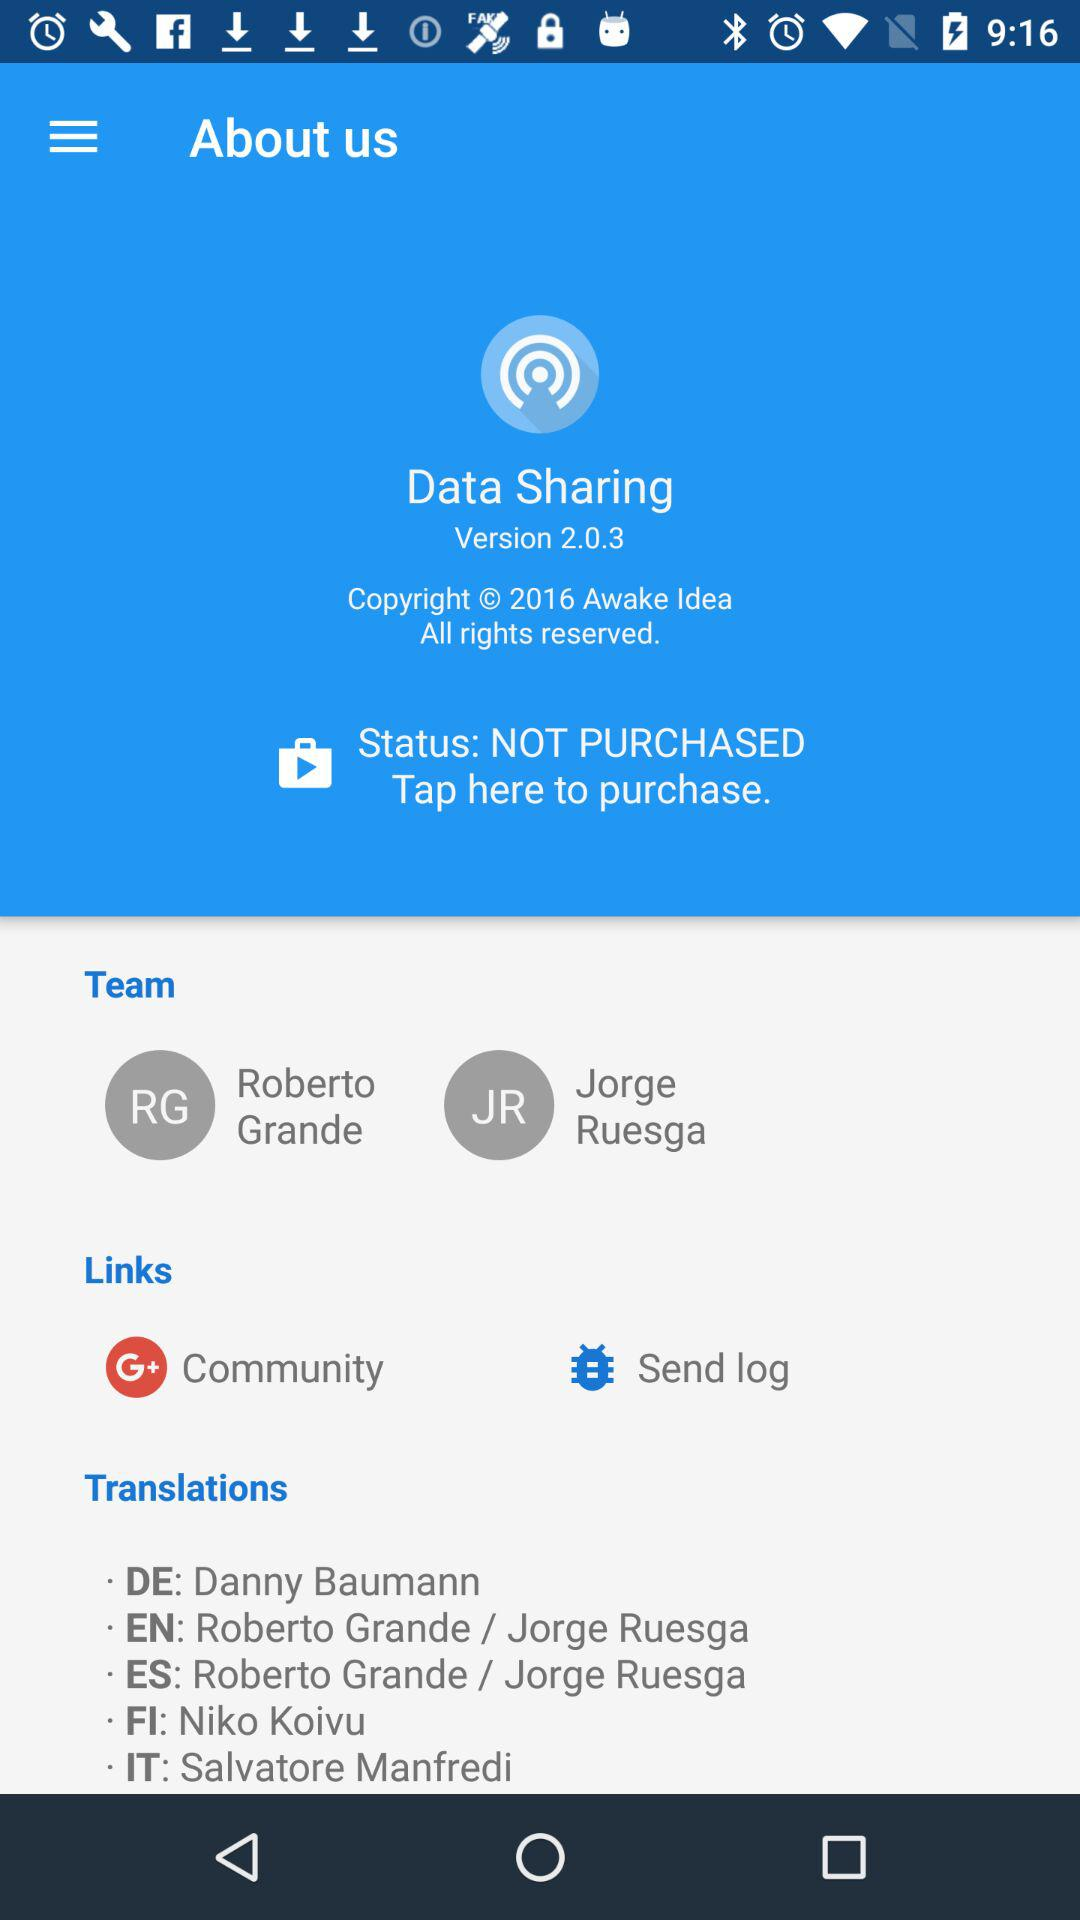What is the status? The status is "NOT PURCHASED". 